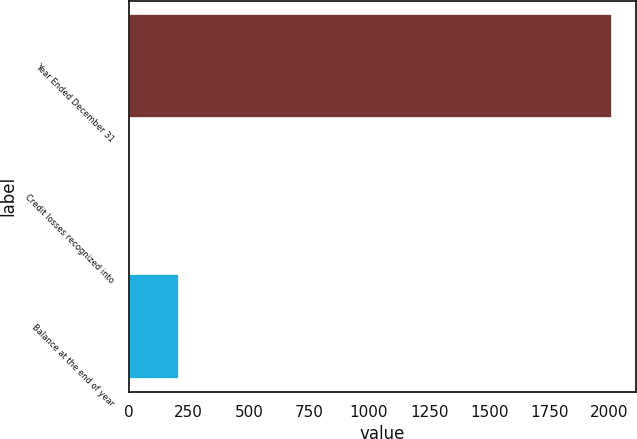Convert chart to OTSL. <chart><loc_0><loc_0><loc_500><loc_500><bar_chart><fcel>Year Ended December 31<fcel>Credit losses recognized into<fcel>Balance at the end of year<nl><fcel>2010<fcel>7<fcel>207.3<nl></chart> 